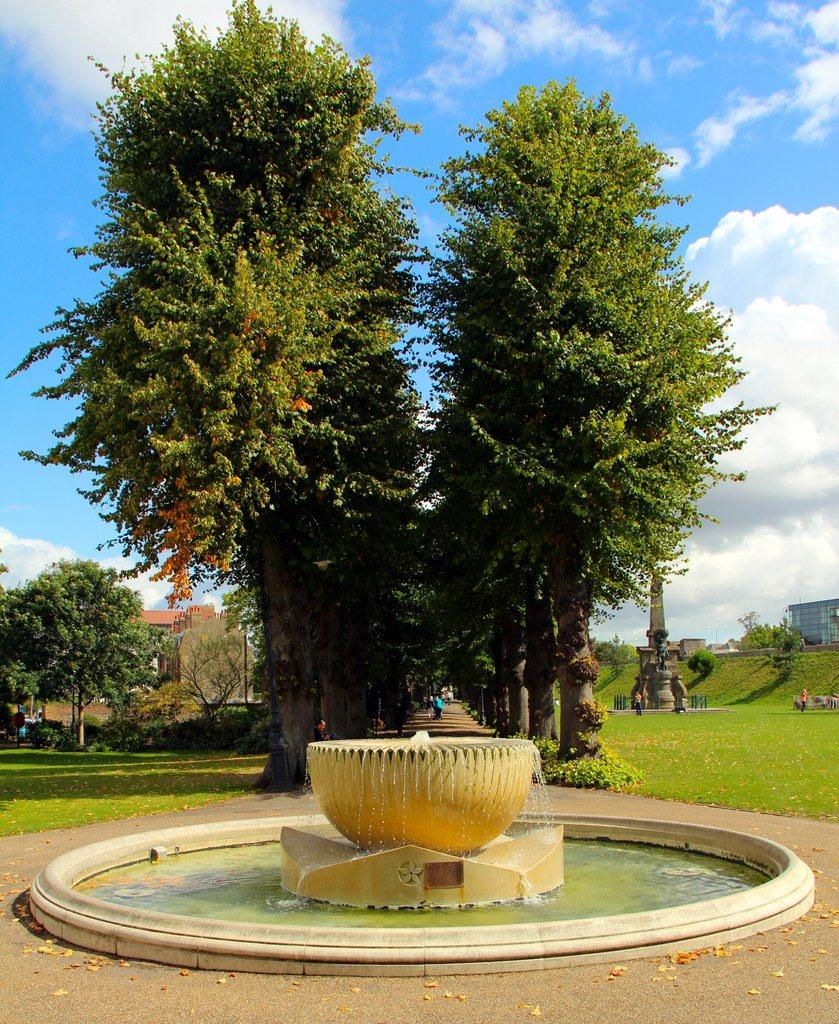What is the main feature in the image? There is a water fountain in the image. What type of natural environment is visible in the image? Grass, trees, and a path are visible in the image. What type of structures can be seen in the image? There are buildings in the image. What is the condition of the sky in the image? The sky is cloudy in the image. Who or what is present in the image? People wearing clothes are present in the image. What question is being asked by the dad in the image? There is no dad or question being asked in the image. 